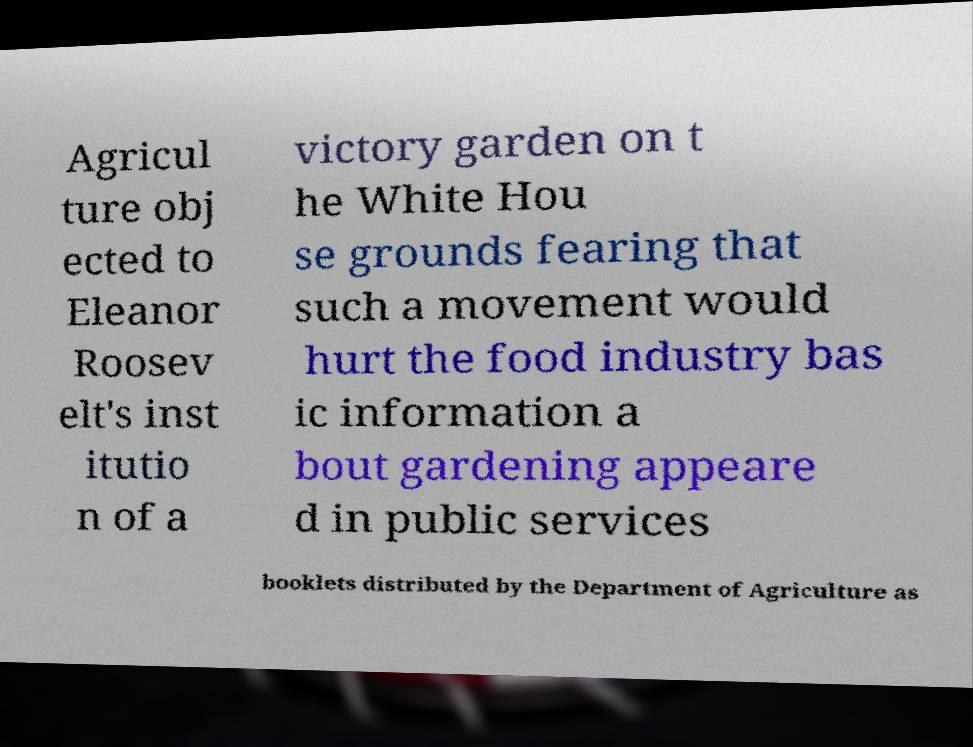Could you extract and type out the text from this image? Agricul ture obj ected to Eleanor Roosev elt's inst itutio n of a victory garden on t he White Hou se grounds fearing that such a movement would hurt the food industry bas ic information a bout gardening appeare d in public services booklets distributed by the Department of Agriculture as 